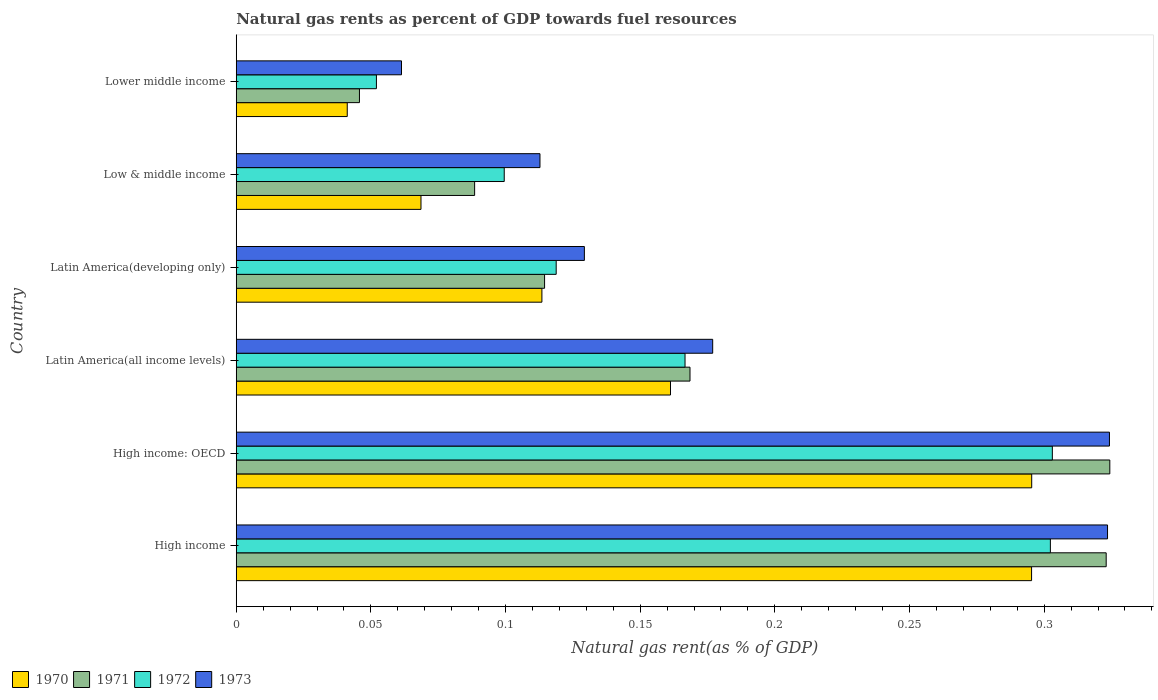How many groups of bars are there?
Offer a very short reply. 6. Are the number of bars on each tick of the Y-axis equal?
Offer a very short reply. Yes. How many bars are there on the 1st tick from the bottom?
Your answer should be very brief. 4. What is the label of the 3rd group of bars from the top?
Provide a short and direct response. Latin America(developing only). What is the natural gas rent in 1973 in Low & middle income?
Keep it short and to the point. 0.11. Across all countries, what is the maximum natural gas rent in 1970?
Provide a short and direct response. 0.3. Across all countries, what is the minimum natural gas rent in 1970?
Provide a short and direct response. 0.04. In which country was the natural gas rent in 1970 maximum?
Your answer should be compact. High income: OECD. In which country was the natural gas rent in 1973 minimum?
Your response must be concise. Lower middle income. What is the total natural gas rent in 1971 in the graph?
Your response must be concise. 1.06. What is the difference between the natural gas rent in 1973 in High income: OECD and that in Latin America(developing only)?
Offer a very short reply. 0.19. What is the difference between the natural gas rent in 1973 in High income and the natural gas rent in 1972 in High income: OECD?
Offer a very short reply. 0.02. What is the average natural gas rent in 1972 per country?
Ensure brevity in your answer.  0.17. What is the difference between the natural gas rent in 1972 and natural gas rent in 1973 in High income: OECD?
Offer a very short reply. -0.02. What is the ratio of the natural gas rent in 1971 in High income to that in Latin America(all income levels)?
Provide a succinct answer. 1.92. Is the difference between the natural gas rent in 1972 in High income and Latin America(all income levels) greater than the difference between the natural gas rent in 1973 in High income and Latin America(all income levels)?
Provide a succinct answer. No. What is the difference between the highest and the second highest natural gas rent in 1970?
Offer a terse response. 4.502023738700567e-5. What is the difference between the highest and the lowest natural gas rent in 1972?
Your answer should be compact. 0.25. In how many countries, is the natural gas rent in 1970 greater than the average natural gas rent in 1970 taken over all countries?
Give a very brief answer. 2. Is it the case that in every country, the sum of the natural gas rent in 1972 and natural gas rent in 1970 is greater than the sum of natural gas rent in 1973 and natural gas rent in 1971?
Your response must be concise. No. What does the 1st bar from the top in Latin America(all income levels) represents?
Your answer should be very brief. 1973. What does the 1st bar from the bottom in Latin America(all income levels) represents?
Your answer should be compact. 1970. How many bars are there?
Offer a very short reply. 24. Are all the bars in the graph horizontal?
Make the answer very short. Yes. What is the difference between two consecutive major ticks on the X-axis?
Provide a succinct answer. 0.05. How many legend labels are there?
Make the answer very short. 4. How are the legend labels stacked?
Provide a succinct answer. Horizontal. What is the title of the graph?
Offer a terse response. Natural gas rents as percent of GDP towards fuel resources. What is the label or title of the X-axis?
Keep it short and to the point. Natural gas rent(as % of GDP). What is the label or title of the Y-axis?
Provide a succinct answer. Country. What is the Natural gas rent(as % of GDP) in 1970 in High income?
Provide a succinct answer. 0.3. What is the Natural gas rent(as % of GDP) in 1971 in High income?
Keep it short and to the point. 0.32. What is the Natural gas rent(as % of GDP) of 1972 in High income?
Give a very brief answer. 0.3. What is the Natural gas rent(as % of GDP) in 1973 in High income?
Provide a short and direct response. 0.32. What is the Natural gas rent(as % of GDP) in 1970 in High income: OECD?
Provide a succinct answer. 0.3. What is the Natural gas rent(as % of GDP) in 1971 in High income: OECD?
Ensure brevity in your answer.  0.32. What is the Natural gas rent(as % of GDP) in 1972 in High income: OECD?
Offer a very short reply. 0.3. What is the Natural gas rent(as % of GDP) in 1973 in High income: OECD?
Offer a very short reply. 0.32. What is the Natural gas rent(as % of GDP) in 1970 in Latin America(all income levels)?
Give a very brief answer. 0.16. What is the Natural gas rent(as % of GDP) in 1971 in Latin America(all income levels)?
Keep it short and to the point. 0.17. What is the Natural gas rent(as % of GDP) of 1972 in Latin America(all income levels)?
Offer a very short reply. 0.17. What is the Natural gas rent(as % of GDP) in 1973 in Latin America(all income levels)?
Your answer should be very brief. 0.18. What is the Natural gas rent(as % of GDP) of 1970 in Latin America(developing only)?
Your answer should be very brief. 0.11. What is the Natural gas rent(as % of GDP) of 1971 in Latin America(developing only)?
Keep it short and to the point. 0.11. What is the Natural gas rent(as % of GDP) in 1972 in Latin America(developing only)?
Your answer should be very brief. 0.12. What is the Natural gas rent(as % of GDP) of 1973 in Latin America(developing only)?
Your response must be concise. 0.13. What is the Natural gas rent(as % of GDP) in 1970 in Low & middle income?
Make the answer very short. 0.07. What is the Natural gas rent(as % of GDP) of 1971 in Low & middle income?
Offer a terse response. 0.09. What is the Natural gas rent(as % of GDP) in 1972 in Low & middle income?
Provide a succinct answer. 0.1. What is the Natural gas rent(as % of GDP) in 1973 in Low & middle income?
Make the answer very short. 0.11. What is the Natural gas rent(as % of GDP) in 1970 in Lower middle income?
Offer a terse response. 0.04. What is the Natural gas rent(as % of GDP) of 1971 in Lower middle income?
Offer a terse response. 0.05. What is the Natural gas rent(as % of GDP) in 1972 in Lower middle income?
Ensure brevity in your answer.  0.05. What is the Natural gas rent(as % of GDP) in 1973 in Lower middle income?
Your response must be concise. 0.06. Across all countries, what is the maximum Natural gas rent(as % of GDP) of 1970?
Offer a terse response. 0.3. Across all countries, what is the maximum Natural gas rent(as % of GDP) of 1971?
Ensure brevity in your answer.  0.32. Across all countries, what is the maximum Natural gas rent(as % of GDP) in 1972?
Offer a very short reply. 0.3. Across all countries, what is the maximum Natural gas rent(as % of GDP) in 1973?
Make the answer very short. 0.32. Across all countries, what is the minimum Natural gas rent(as % of GDP) of 1970?
Your answer should be very brief. 0.04. Across all countries, what is the minimum Natural gas rent(as % of GDP) in 1971?
Provide a short and direct response. 0.05. Across all countries, what is the minimum Natural gas rent(as % of GDP) in 1972?
Your answer should be very brief. 0.05. Across all countries, what is the minimum Natural gas rent(as % of GDP) in 1973?
Give a very brief answer. 0.06. What is the total Natural gas rent(as % of GDP) in 1970 in the graph?
Ensure brevity in your answer.  0.98. What is the total Natural gas rent(as % of GDP) of 1971 in the graph?
Ensure brevity in your answer.  1.06. What is the total Natural gas rent(as % of GDP) of 1972 in the graph?
Ensure brevity in your answer.  1.04. What is the total Natural gas rent(as % of GDP) of 1973 in the graph?
Make the answer very short. 1.13. What is the difference between the Natural gas rent(as % of GDP) in 1971 in High income and that in High income: OECD?
Your response must be concise. -0. What is the difference between the Natural gas rent(as % of GDP) of 1972 in High income and that in High income: OECD?
Ensure brevity in your answer.  -0. What is the difference between the Natural gas rent(as % of GDP) in 1973 in High income and that in High income: OECD?
Your response must be concise. -0. What is the difference between the Natural gas rent(as % of GDP) of 1970 in High income and that in Latin America(all income levels)?
Keep it short and to the point. 0.13. What is the difference between the Natural gas rent(as % of GDP) of 1971 in High income and that in Latin America(all income levels)?
Offer a terse response. 0.15. What is the difference between the Natural gas rent(as % of GDP) of 1972 in High income and that in Latin America(all income levels)?
Make the answer very short. 0.14. What is the difference between the Natural gas rent(as % of GDP) in 1973 in High income and that in Latin America(all income levels)?
Provide a short and direct response. 0.15. What is the difference between the Natural gas rent(as % of GDP) in 1970 in High income and that in Latin America(developing only)?
Provide a succinct answer. 0.18. What is the difference between the Natural gas rent(as % of GDP) in 1971 in High income and that in Latin America(developing only)?
Keep it short and to the point. 0.21. What is the difference between the Natural gas rent(as % of GDP) in 1972 in High income and that in Latin America(developing only)?
Offer a very short reply. 0.18. What is the difference between the Natural gas rent(as % of GDP) in 1973 in High income and that in Latin America(developing only)?
Make the answer very short. 0.19. What is the difference between the Natural gas rent(as % of GDP) of 1970 in High income and that in Low & middle income?
Offer a very short reply. 0.23. What is the difference between the Natural gas rent(as % of GDP) of 1971 in High income and that in Low & middle income?
Keep it short and to the point. 0.23. What is the difference between the Natural gas rent(as % of GDP) in 1972 in High income and that in Low & middle income?
Provide a short and direct response. 0.2. What is the difference between the Natural gas rent(as % of GDP) of 1973 in High income and that in Low & middle income?
Ensure brevity in your answer.  0.21. What is the difference between the Natural gas rent(as % of GDP) of 1970 in High income and that in Lower middle income?
Provide a succinct answer. 0.25. What is the difference between the Natural gas rent(as % of GDP) of 1971 in High income and that in Lower middle income?
Your answer should be compact. 0.28. What is the difference between the Natural gas rent(as % of GDP) in 1972 in High income and that in Lower middle income?
Your response must be concise. 0.25. What is the difference between the Natural gas rent(as % of GDP) in 1973 in High income and that in Lower middle income?
Make the answer very short. 0.26. What is the difference between the Natural gas rent(as % of GDP) of 1970 in High income: OECD and that in Latin America(all income levels)?
Offer a terse response. 0.13. What is the difference between the Natural gas rent(as % of GDP) of 1971 in High income: OECD and that in Latin America(all income levels)?
Provide a succinct answer. 0.16. What is the difference between the Natural gas rent(as % of GDP) of 1972 in High income: OECD and that in Latin America(all income levels)?
Make the answer very short. 0.14. What is the difference between the Natural gas rent(as % of GDP) of 1973 in High income: OECD and that in Latin America(all income levels)?
Give a very brief answer. 0.15. What is the difference between the Natural gas rent(as % of GDP) in 1970 in High income: OECD and that in Latin America(developing only)?
Your answer should be very brief. 0.18. What is the difference between the Natural gas rent(as % of GDP) in 1971 in High income: OECD and that in Latin America(developing only)?
Your answer should be compact. 0.21. What is the difference between the Natural gas rent(as % of GDP) in 1972 in High income: OECD and that in Latin America(developing only)?
Offer a terse response. 0.18. What is the difference between the Natural gas rent(as % of GDP) of 1973 in High income: OECD and that in Latin America(developing only)?
Offer a terse response. 0.2. What is the difference between the Natural gas rent(as % of GDP) of 1970 in High income: OECD and that in Low & middle income?
Make the answer very short. 0.23. What is the difference between the Natural gas rent(as % of GDP) in 1971 in High income: OECD and that in Low & middle income?
Your answer should be compact. 0.24. What is the difference between the Natural gas rent(as % of GDP) of 1972 in High income: OECD and that in Low & middle income?
Keep it short and to the point. 0.2. What is the difference between the Natural gas rent(as % of GDP) in 1973 in High income: OECD and that in Low & middle income?
Your answer should be very brief. 0.21. What is the difference between the Natural gas rent(as % of GDP) of 1970 in High income: OECD and that in Lower middle income?
Offer a very short reply. 0.25. What is the difference between the Natural gas rent(as % of GDP) in 1971 in High income: OECD and that in Lower middle income?
Ensure brevity in your answer.  0.28. What is the difference between the Natural gas rent(as % of GDP) in 1972 in High income: OECD and that in Lower middle income?
Offer a terse response. 0.25. What is the difference between the Natural gas rent(as % of GDP) of 1973 in High income: OECD and that in Lower middle income?
Provide a succinct answer. 0.26. What is the difference between the Natural gas rent(as % of GDP) in 1970 in Latin America(all income levels) and that in Latin America(developing only)?
Your response must be concise. 0.05. What is the difference between the Natural gas rent(as % of GDP) in 1971 in Latin America(all income levels) and that in Latin America(developing only)?
Your answer should be very brief. 0.05. What is the difference between the Natural gas rent(as % of GDP) of 1972 in Latin America(all income levels) and that in Latin America(developing only)?
Offer a terse response. 0.05. What is the difference between the Natural gas rent(as % of GDP) in 1973 in Latin America(all income levels) and that in Latin America(developing only)?
Provide a succinct answer. 0.05. What is the difference between the Natural gas rent(as % of GDP) of 1970 in Latin America(all income levels) and that in Low & middle income?
Your answer should be compact. 0.09. What is the difference between the Natural gas rent(as % of GDP) of 1972 in Latin America(all income levels) and that in Low & middle income?
Provide a succinct answer. 0.07. What is the difference between the Natural gas rent(as % of GDP) of 1973 in Latin America(all income levels) and that in Low & middle income?
Your answer should be very brief. 0.06. What is the difference between the Natural gas rent(as % of GDP) of 1970 in Latin America(all income levels) and that in Lower middle income?
Offer a very short reply. 0.12. What is the difference between the Natural gas rent(as % of GDP) of 1971 in Latin America(all income levels) and that in Lower middle income?
Keep it short and to the point. 0.12. What is the difference between the Natural gas rent(as % of GDP) in 1972 in Latin America(all income levels) and that in Lower middle income?
Provide a short and direct response. 0.11. What is the difference between the Natural gas rent(as % of GDP) of 1973 in Latin America(all income levels) and that in Lower middle income?
Give a very brief answer. 0.12. What is the difference between the Natural gas rent(as % of GDP) of 1970 in Latin America(developing only) and that in Low & middle income?
Keep it short and to the point. 0.04. What is the difference between the Natural gas rent(as % of GDP) of 1971 in Latin America(developing only) and that in Low & middle income?
Keep it short and to the point. 0.03. What is the difference between the Natural gas rent(as % of GDP) in 1972 in Latin America(developing only) and that in Low & middle income?
Keep it short and to the point. 0.02. What is the difference between the Natural gas rent(as % of GDP) of 1973 in Latin America(developing only) and that in Low & middle income?
Offer a terse response. 0.02. What is the difference between the Natural gas rent(as % of GDP) of 1970 in Latin America(developing only) and that in Lower middle income?
Offer a very short reply. 0.07. What is the difference between the Natural gas rent(as % of GDP) in 1971 in Latin America(developing only) and that in Lower middle income?
Give a very brief answer. 0.07. What is the difference between the Natural gas rent(as % of GDP) of 1972 in Latin America(developing only) and that in Lower middle income?
Ensure brevity in your answer.  0.07. What is the difference between the Natural gas rent(as % of GDP) of 1973 in Latin America(developing only) and that in Lower middle income?
Your answer should be compact. 0.07. What is the difference between the Natural gas rent(as % of GDP) in 1970 in Low & middle income and that in Lower middle income?
Make the answer very short. 0.03. What is the difference between the Natural gas rent(as % of GDP) of 1971 in Low & middle income and that in Lower middle income?
Offer a terse response. 0.04. What is the difference between the Natural gas rent(as % of GDP) in 1972 in Low & middle income and that in Lower middle income?
Make the answer very short. 0.05. What is the difference between the Natural gas rent(as % of GDP) in 1973 in Low & middle income and that in Lower middle income?
Your response must be concise. 0.05. What is the difference between the Natural gas rent(as % of GDP) of 1970 in High income and the Natural gas rent(as % of GDP) of 1971 in High income: OECD?
Offer a very short reply. -0.03. What is the difference between the Natural gas rent(as % of GDP) in 1970 in High income and the Natural gas rent(as % of GDP) in 1972 in High income: OECD?
Your answer should be very brief. -0.01. What is the difference between the Natural gas rent(as % of GDP) of 1970 in High income and the Natural gas rent(as % of GDP) of 1973 in High income: OECD?
Your response must be concise. -0.03. What is the difference between the Natural gas rent(as % of GDP) in 1971 in High income and the Natural gas rent(as % of GDP) in 1973 in High income: OECD?
Provide a succinct answer. -0. What is the difference between the Natural gas rent(as % of GDP) in 1972 in High income and the Natural gas rent(as % of GDP) in 1973 in High income: OECD?
Provide a succinct answer. -0.02. What is the difference between the Natural gas rent(as % of GDP) of 1970 in High income and the Natural gas rent(as % of GDP) of 1971 in Latin America(all income levels)?
Ensure brevity in your answer.  0.13. What is the difference between the Natural gas rent(as % of GDP) in 1970 in High income and the Natural gas rent(as % of GDP) in 1972 in Latin America(all income levels)?
Offer a very short reply. 0.13. What is the difference between the Natural gas rent(as % of GDP) in 1970 in High income and the Natural gas rent(as % of GDP) in 1973 in Latin America(all income levels)?
Ensure brevity in your answer.  0.12. What is the difference between the Natural gas rent(as % of GDP) of 1971 in High income and the Natural gas rent(as % of GDP) of 1972 in Latin America(all income levels)?
Offer a very short reply. 0.16. What is the difference between the Natural gas rent(as % of GDP) of 1971 in High income and the Natural gas rent(as % of GDP) of 1973 in Latin America(all income levels)?
Your response must be concise. 0.15. What is the difference between the Natural gas rent(as % of GDP) in 1972 in High income and the Natural gas rent(as % of GDP) in 1973 in Latin America(all income levels)?
Your answer should be compact. 0.13. What is the difference between the Natural gas rent(as % of GDP) in 1970 in High income and the Natural gas rent(as % of GDP) in 1971 in Latin America(developing only)?
Keep it short and to the point. 0.18. What is the difference between the Natural gas rent(as % of GDP) of 1970 in High income and the Natural gas rent(as % of GDP) of 1972 in Latin America(developing only)?
Offer a terse response. 0.18. What is the difference between the Natural gas rent(as % of GDP) of 1970 in High income and the Natural gas rent(as % of GDP) of 1973 in Latin America(developing only)?
Your answer should be very brief. 0.17. What is the difference between the Natural gas rent(as % of GDP) of 1971 in High income and the Natural gas rent(as % of GDP) of 1972 in Latin America(developing only)?
Provide a succinct answer. 0.2. What is the difference between the Natural gas rent(as % of GDP) in 1971 in High income and the Natural gas rent(as % of GDP) in 1973 in Latin America(developing only)?
Make the answer very short. 0.19. What is the difference between the Natural gas rent(as % of GDP) of 1972 in High income and the Natural gas rent(as % of GDP) of 1973 in Latin America(developing only)?
Your answer should be compact. 0.17. What is the difference between the Natural gas rent(as % of GDP) in 1970 in High income and the Natural gas rent(as % of GDP) in 1971 in Low & middle income?
Keep it short and to the point. 0.21. What is the difference between the Natural gas rent(as % of GDP) in 1970 in High income and the Natural gas rent(as % of GDP) in 1972 in Low & middle income?
Make the answer very short. 0.2. What is the difference between the Natural gas rent(as % of GDP) in 1970 in High income and the Natural gas rent(as % of GDP) in 1973 in Low & middle income?
Provide a short and direct response. 0.18. What is the difference between the Natural gas rent(as % of GDP) in 1971 in High income and the Natural gas rent(as % of GDP) in 1972 in Low & middle income?
Your answer should be very brief. 0.22. What is the difference between the Natural gas rent(as % of GDP) in 1971 in High income and the Natural gas rent(as % of GDP) in 1973 in Low & middle income?
Ensure brevity in your answer.  0.21. What is the difference between the Natural gas rent(as % of GDP) in 1972 in High income and the Natural gas rent(as % of GDP) in 1973 in Low & middle income?
Your response must be concise. 0.19. What is the difference between the Natural gas rent(as % of GDP) in 1970 in High income and the Natural gas rent(as % of GDP) in 1971 in Lower middle income?
Provide a short and direct response. 0.25. What is the difference between the Natural gas rent(as % of GDP) of 1970 in High income and the Natural gas rent(as % of GDP) of 1972 in Lower middle income?
Your answer should be very brief. 0.24. What is the difference between the Natural gas rent(as % of GDP) in 1970 in High income and the Natural gas rent(as % of GDP) in 1973 in Lower middle income?
Your answer should be very brief. 0.23. What is the difference between the Natural gas rent(as % of GDP) of 1971 in High income and the Natural gas rent(as % of GDP) of 1972 in Lower middle income?
Offer a very short reply. 0.27. What is the difference between the Natural gas rent(as % of GDP) in 1971 in High income and the Natural gas rent(as % of GDP) in 1973 in Lower middle income?
Give a very brief answer. 0.26. What is the difference between the Natural gas rent(as % of GDP) of 1972 in High income and the Natural gas rent(as % of GDP) of 1973 in Lower middle income?
Offer a terse response. 0.24. What is the difference between the Natural gas rent(as % of GDP) of 1970 in High income: OECD and the Natural gas rent(as % of GDP) of 1971 in Latin America(all income levels)?
Keep it short and to the point. 0.13. What is the difference between the Natural gas rent(as % of GDP) in 1970 in High income: OECD and the Natural gas rent(as % of GDP) in 1972 in Latin America(all income levels)?
Your answer should be compact. 0.13. What is the difference between the Natural gas rent(as % of GDP) in 1970 in High income: OECD and the Natural gas rent(as % of GDP) in 1973 in Latin America(all income levels)?
Give a very brief answer. 0.12. What is the difference between the Natural gas rent(as % of GDP) in 1971 in High income: OECD and the Natural gas rent(as % of GDP) in 1972 in Latin America(all income levels)?
Your answer should be very brief. 0.16. What is the difference between the Natural gas rent(as % of GDP) in 1971 in High income: OECD and the Natural gas rent(as % of GDP) in 1973 in Latin America(all income levels)?
Your response must be concise. 0.15. What is the difference between the Natural gas rent(as % of GDP) in 1972 in High income: OECD and the Natural gas rent(as % of GDP) in 1973 in Latin America(all income levels)?
Give a very brief answer. 0.13. What is the difference between the Natural gas rent(as % of GDP) in 1970 in High income: OECD and the Natural gas rent(as % of GDP) in 1971 in Latin America(developing only)?
Your response must be concise. 0.18. What is the difference between the Natural gas rent(as % of GDP) of 1970 in High income: OECD and the Natural gas rent(as % of GDP) of 1972 in Latin America(developing only)?
Offer a very short reply. 0.18. What is the difference between the Natural gas rent(as % of GDP) of 1970 in High income: OECD and the Natural gas rent(as % of GDP) of 1973 in Latin America(developing only)?
Your answer should be compact. 0.17. What is the difference between the Natural gas rent(as % of GDP) of 1971 in High income: OECD and the Natural gas rent(as % of GDP) of 1972 in Latin America(developing only)?
Your response must be concise. 0.21. What is the difference between the Natural gas rent(as % of GDP) in 1971 in High income: OECD and the Natural gas rent(as % of GDP) in 1973 in Latin America(developing only)?
Offer a very short reply. 0.2. What is the difference between the Natural gas rent(as % of GDP) of 1972 in High income: OECD and the Natural gas rent(as % of GDP) of 1973 in Latin America(developing only)?
Give a very brief answer. 0.17. What is the difference between the Natural gas rent(as % of GDP) of 1970 in High income: OECD and the Natural gas rent(as % of GDP) of 1971 in Low & middle income?
Your answer should be very brief. 0.21. What is the difference between the Natural gas rent(as % of GDP) in 1970 in High income: OECD and the Natural gas rent(as % of GDP) in 1972 in Low & middle income?
Give a very brief answer. 0.2. What is the difference between the Natural gas rent(as % of GDP) of 1970 in High income: OECD and the Natural gas rent(as % of GDP) of 1973 in Low & middle income?
Offer a very short reply. 0.18. What is the difference between the Natural gas rent(as % of GDP) in 1971 in High income: OECD and the Natural gas rent(as % of GDP) in 1972 in Low & middle income?
Your answer should be compact. 0.22. What is the difference between the Natural gas rent(as % of GDP) in 1971 in High income: OECD and the Natural gas rent(as % of GDP) in 1973 in Low & middle income?
Make the answer very short. 0.21. What is the difference between the Natural gas rent(as % of GDP) of 1972 in High income: OECD and the Natural gas rent(as % of GDP) of 1973 in Low & middle income?
Your answer should be very brief. 0.19. What is the difference between the Natural gas rent(as % of GDP) of 1970 in High income: OECD and the Natural gas rent(as % of GDP) of 1971 in Lower middle income?
Offer a terse response. 0.25. What is the difference between the Natural gas rent(as % of GDP) of 1970 in High income: OECD and the Natural gas rent(as % of GDP) of 1972 in Lower middle income?
Provide a succinct answer. 0.24. What is the difference between the Natural gas rent(as % of GDP) of 1970 in High income: OECD and the Natural gas rent(as % of GDP) of 1973 in Lower middle income?
Provide a succinct answer. 0.23. What is the difference between the Natural gas rent(as % of GDP) of 1971 in High income: OECD and the Natural gas rent(as % of GDP) of 1972 in Lower middle income?
Your answer should be compact. 0.27. What is the difference between the Natural gas rent(as % of GDP) in 1971 in High income: OECD and the Natural gas rent(as % of GDP) in 1973 in Lower middle income?
Your answer should be compact. 0.26. What is the difference between the Natural gas rent(as % of GDP) of 1972 in High income: OECD and the Natural gas rent(as % of GDP) of 1973 in Lower middle income?
Provide a succinct answer. 0.24. What is the difference between the Natural gas rent(as % of GDP) of 1970 in Latin America(all income levels) and the Natural gas rent(as % of GDP) of 1971 in Latin America(developing only)?
Offer a very short reply. 0.05. What is the difference between the Natural gas rent(as % of GDP) of 1970 in Latin America(all income levels) and the Natural gas rent(as % of GDP) of 1972 in Latin America(developing only)?
Make the answer very short. 0.04. What is the difference between the Natural gas rent(as % of GDP) in 1970 in Latin America(all income levels) and the Natural gas rent(as % of GDP) in 1973 in Latin America(developing only)?
Make the answer very short. 0.03. What is the difference between the Natural gas rent(as % of GDP) in 1971 in Latin America(all income levels) and the Natural gas rent(as % of GDP) in 1972 in Latin America(developing only)?
Ensure brevity in your answer.  0.05. What is the difference between the Natural gas rent(as % of GDP) in 1971 in Latin America(all income levels) and the Natural gas rent(as % of GDP) in 1973 in Latin America(developing only)?
Your answer should be very brief. 0.04. What is the difference between the Natural gas rent(as % of GDP) of 1972 in Latin America(all income levels) and the Natural gas rent(as % of GDP) of 1973 in Latin America(developing only)?
Offer a very short reply. 0.04. What is the difference between the Natural gas rent(as % of GDP) in 1970 in Latin America(all income levels) and the Natural gas rent(as % of GDP) in 1971 in Low & middle income?
Provide a succinct answer. 0.07. What is the difference between the Natural gas rent(as % of GDP) of 1970 in Latin America(all income levels) and the Natural gas rent(as % of GDP) of 1972 in Low & middle income?
Ensure brevity in your answer.  0.06. What is the difference between the Natural gas rent(as % of GDP) in 1970 in Latin America(all income levels) and the Natural gas rent(as % of GDP) in 1973 in Low & middle income?
Provide a succinct answer. 0.05. What is the difference between the Natural gas rent(as % of GDP) of 1971 in Latin America(all income levels) and the Natural gas rent(as % of GDP) of 1972 in Low & middle income?
Your response must be concise. 0.07. What is the difference between the Natural gas rent(as % of GDP) in 1971 in Latin America(all income levels) and the Natural gas rent(as % of GDP) in 1973 in Low & middle income?
Keep it short and to the point. 0.06. What is the difference between the Natural gas rent(as % of GDP) of 1972 in Latin America(all income levels) and the Natural gas rent(as % of GDP) of 1973 in Low & middle income?
Provide a succinct answer. 0.05. What is the difference between the Natural gas rent(as % of GDP) of 1970 in Latin America(all income levels) and the Natural gas rent(as % of GDP) of 1971 in Lower middle income?
Ensure brevity in your answer.  0.12. What is the difference between the Natural gas rent(as % of GDP) in 1970 in Latin America(all income levels) and the Natural gas rent(as % of GDP) in 1972 in Lower middle income?
Provide a succinct answer. 0.11. What is the difference between the Natural gas rent(as % of GDP) in 1970 in Latin America(all income levels) and the Natural gas rent(as % of GDP) in 1973 in Lower middle income?
Provide a short and direct response. 0.1. What is the difference between the Natural gas rent(as % of GDP) in 1971 in Latin America(all income levels) and the Natural gas rent(as % of GDP) in 1972 in Lower middle income?
Your answer should be compact. 0.12. What is the difference between the Natural gas rent(as % of GDP) in 1971 in Latin America(all income levels) and the Natural gas rent(as % of GDP) in 1973 in Lower middle income?
Offer a very short reply. 0.11. What is the difference between the Natural gas rent(as % of GDP) of 1972 in Latin America(all income levels) and the Natural gas rent(as % of GDP) of 1973 in Lower middle income?
Provide a succinct answer. 0.11. What is the difference between the Natural gas rent(as % of GDP) of 1970 in Latin America(developing only) and the Natural gas rent(as % of GDP) of 1971 in Low & middle income?
Your answer should be very brief. 0.03. What is the difference between the Natural gas rent(as % of GDP) of 1970 in Latin America(developing only) and the Natural gas rent(as % of GDP) of 1972 in Low & middle income?
Your answer should be compact. 0.01. What is the difference between the Natural gas rent(as % of GDP) of 1970 in Latin America(developing only) and the Natural gas rent(as % of GDP) of 1973 in Low & middle income?
Your answer should be compact. 0. What is the difference between the Natural gas rent(as % of GDP) in 1971 in Latin America(developing only) and the Natural gas rent(as % of GDP) in 1972 in Low & middle income?
Provide a succinct answer. 0.01. What is the difference between the Natural gas rent(as % of GDP) of 1971 in Latin America(developing only) and the Natural gas rent(as % of GDP) of 1973 in Low & middle income?
Provide a succinct answer. 0. What is the difference between the Natural gas rent(as % of GDP) of 1972 in Latin America(developing only) and the Natural gas rent(as % of GDP) of 1973 in Low & middle income?
Keep it short and to the point. 0.01. What is the difference between the Natural gas rent(as % of GDP) in 1970 in Latin America(developing only) and the Natural gas rent(as % of GDP) in 1971 in Lower middle income?
Give a very brief answer. 0.07. What is the difference between the Natural gas rent(as % of GDP) in 1970 in Latin America(developing only) and the Natural gas rent(as % of GDP) in 1972 in Lower middle income?
Offer a terse response. 0.06. What is the difference between the Natural gas rent(as % of GDP) in 1970 in Latin America(developing only) and the Natural gas rent(as % of GDP) in 1973 in Lower middle income?
Provide a short and direct response. 0.05. What is the difference between the Natural gas rent(as % of GDP) of 1971 in Latin America(developing only) and the Natural gas rent(as % of GDP) of 1972 in Lower middle income?
Offer a terse response. 0.06. What is the difference between the Natural gas rent(as % of GDP) in 1971 in Latin America(developing only) and the Natural gas rent(as % of GDP) in 1973 in Lower middle income?
Ensure brevity in your answer.  0.05. What is the difference between the Natural gas rent(as % of GDP) in 1972 in Latin America(developing only) and the Natural gas rent(as % of GDP) in 1973 in Lower middle income?
Your answer should be very brief. 0.06. What is the difference between the Natural gas rent(as % of GDP) of 1970 in Low & middle income and the Natural gas rent(as % of GDP) of 1971 in Lower middle income?
Offer a very short reply. 0.02. What is the difference between the Natural gas rent(as % of GDP) of 1970 in Low & middle income and the Natural gas rent(as % of GDP) of 1972 in Lower middle income?
Offer a terse response. 0.02. What is the difference between the Natural gas rent(as % of GDP) in 1970 in Low & middle income and the Natural gas rent(as % of GDP) in 1973 in Lower middle income?
Ensure brevity in your answer.  0.01. What is the difference between the Natural gas rent(as % of GDP) of 1971 in Low & middle income and the Natural gas rent(as % of GDP) of 1972 in Lower middle income?
Offer a terse response. 0.04. What is the difference between the Natural gas rent(as % of GDP) in 1971 in Low & middle income and the Natural gas rent(as % of GDP) in 1973 in Lower middle income?
Make the answer very short. 0.03. What is the difference between the Natural gas rent(as % of GDP) of 1972 in Low & middle income and the Natural gas rent(as % of GDP) of 1973 in Lower middle income?
Your answer should be compact. 0.04. What is the average Natural gas rent(as % of GDP) of 1970 per country?
Give a very brief answer. 0.16. What is the average Natural gas rent(as % of GDP) of 1971 per country?
Make the answer very short. 0.18. What is the average Natural gas rent(as % of GDP) of 1972 per country?
Ensure brevity in your answer.  0.17. What is the average Natural gas rent(as % of GDP) in 1973 per country?
Keep it short and to the point. 0.19. What is the difference between the Natural gas rent(as % of GDP) of 1970 and Natural gas rent(as % of GDP) of 1971 in High income?
Ensure brevity in your answer.  -0.03. What is the difference between the Natural gas rent(as % of GDP) in 1970 and Natural gas rent(as % of GDP) in 1972 in High income?
Ensure brevity in your answer.  -0.01. What is the difference between the Natural gas rent(as % of GDP) in 1970 and Natural gas rent(as % of GDP) in 1973 in High income?
Ensure brevity in your answer.  -0.03. What is the difference between the Natural gas rent(as % of GDP) in 1971 and Natural gas rent(as % of GDP) in 1972 in High income?
Offer a terse response. 0.02. What is the difference between the Natural gas rent(as % of GDP) of 1971 and Natural gas rent(as % of GDP) of 1973 in High income?
Make the answer very short. -0. What is the difference between the Natural gas rent(as % of GDP) of 1972 and Natural gas rent(as % of GDP) of 1973 in High income?
Make the answer very short. -0.02. What is the difference between the Natural gas rent(as % of GDP) in 1970 and Natural gas rent(as % of GDP) in 1971 in High income: OECD?
Keep it short and to the point. -0.03. What is the difference between the Natural gas rent(as % of GDP) in 1970 and Natural gas rent(as % of GDP) in 1972 in High income: OECD?
Give a very brief answer. -0.01. What is the difference between the Natural gas rent(as % of GDP) of 1970 and Natural gas rent(as % of GDP) of 1973 in High income: OECD?
Offer a very short reply. -0.03. What is the difference between the Natural gas rent(as % of GDP) of 1971 and Natural gas rent(as % of GDP) of 1972 in High income: OECD?
Your answer should be very brief. 0.02. What is the difference between the Natural gas rent(as % of GDP) of 1971 and Natural gas rent(as % of GDP) of 1973 in High income: OECD?
Offer a terse response. 0. What is the difference between the Natural gas rent(as % of GDP) in 1972 and Natural gas rent(as % of GDP) in 1973 in High income: OECD?
Ensure brevity in your answer.  -0.02. What is the difference between the Natural gas rent(as % of GDP) of 1970 and Natural gas rent(as % of GDP) of 1971 in Latin America(all income levels)?
Your answer should be compact. -0.01. What is the difference between the Natural gas rent(as % of GDP) of 1970 and Natural gas rent(as % of GDP) of 1972 in Latin America(all income levels)?
Provide a succinct answer. -0.01. What is the difference between the Natural gas rent(as % of GDP) in 1970 and Natural gas rent(as % of GDP) in 1973 in Latin America(all income levels)?
Ensure brevity in your answer.  -0.02. What is the difference between the Natural gas rent(as % of GDP) of 1971 and Natural gas rent(as % of GDP) of 1972 in Latin America(all income levels)?
Ensure brevity in your answer.  0. What is the difference between the Natural gas rent(as % of GDP) of 1971 and Natural gas rent(as % of GDP) of 1973 in Latin America(all income levels)?
Ensure brevity in your answer.  -0.01. What is the difference between the Natural gas rent(as % of GDP) in 1972 and Natural gas rent(as % of GDP) in 1973 in Latin America(all income levels)?
Offer a very short reply. -0.01. What is the difference between the Natural gas rent(as % of GDP) of 1970 and Natural gas rent(as % of GDP) of 1971 in Latin America(developing only)?
Provide a short and direct response. -0. What is the difference between the Natural gas rent(as % of GDP) in 1970 and Natural gas rent(as % of GDP) in 1972 in Latin America(developing only)?
Ensure brevity in your answer.  -0.01. What is the difference between the Natural gas rent(as % of GDP) of 1970 and Natural gas rent(as % of GDP) of 1973 in Latin America(developing only)?
Give a very brief answer. -0.02. What is the difference between the Natural gas rent(as % of GDP) of 1971 and Natural gas rent(as % of GDP) of 1972 in Latin America(developing only)?
Provide a succinct answer. -0. What is the difference between the Natural gas rent(as % of GDP) in 1971 and Natural gas rent(as % of GDP) in 1973 in Latin America(developing only)?
Provide a succinct answer. -0.01. What is the difference between the Natural gas rent(as % of GDP) in 1972 and Natural gas rent(as % of GDP) in 1973 in Latin America(developing only)?
Offer a very short reply. -0.01. What is the difference between the Natural gas rent(as % of GDP) of 1970 and Natural gas rent(as % of GDP) of 1971 in Low & middle income?
Offer a very short reply. -0.02. What is the difference between the Natural gas rent(as % of GDP) of 1970 and Natural gas rent(as % of GDP) of 1972 in Low & middle income?
Ensure brevity in your answer.  -0.03. What is the difference between the Natural gas rent(as % of GDP) in 1970 and Natural gas rent(as % of GDP) in 1973 in Low & middle income?
Your answer should be compact. -0.04. What is the difference between the Natural gas rent(as % of GDP) of 1971 and Natural gas rent(as % of GDP) of 1972 in Low & middle income?
Your answer should be compact. -0.01. What is the difference between the Natural gas rent(as % of GDP) of 1971 and Natural gas rent(as % of GDP) of 1973 in Low & middle income?
Provide a short and direct response. -0.02. What is the difference between the Natural gas rent(as % of GDP) in 1972 and Natural gas rent(as % of GDP) in 1973 in Low & middle income?
Keep it short and to the point. -0.01. What is the difference between the Natural gas rent(as % of GDP) in 1970 and Natural gas rent(as % of GDP) in 1971 in Lower middle income?
Provide a short and direct response. -0. What is the difference between the Natural gas rent(as % of GDP) of 1970 and Natural gas rent(as % of GDP) of 1972 in Lower middle income?
Make the answer very short. -0.01. What is the difference between the Natural gas rent(as % of GDP) in 1970 and Natural gas rent(as % of GDP) in 1973 in Lower middle income?
Provide a succinct answer. -0.02. What is the difference between the Natural gas rent(as % of GDP) of 1971 and Natural gas rent(as % of GDP) of 1972 in Lower middle income?
Your answer should be compact. -0.01. What is the difference between the Natural gas rent(as % of GDP) in 1971 and Natural gas rent(as % of GDP) in 1973 in Lower middle income?
Offer a very short reply. -0.02. What is the difference between the Natural gas rent(as % of GDP) in 1972 and Natural gas rent(as % of GDP) in 1973 in Lower middle income?
Your answer should be compact. -0.01. What is the ratio of the Natural gas rent(as % of GDP) in 1971 in High income to that in High income: OECD?
Provide a succinct answer. 1. What is the ratio of the Natural gas rent(as % of GDP) in 1973 in High income to that in High income: OECD?
Give a very brief answer. 1. What is the ratio of the Natural gas rent(as % of GDP) in 1970 in High income to that in Latin America(all income levels)?
Provide a succinct answer. 1.83. What is the ratio of the Natural gas rent(as % of GDP) of 1971 in High income to that in Latin America(all income levels)?
Ensure brevity in your answer.  1.92. What is the ratio of the Natural gas rent(as % of GDP) in 1972 in High income to that in Latin America(all income levels)?
Keep it short and to the point. 1.81. What is the ratio of the Natural gas rent(as % of GDP) of 1973 in High income to that in Latin America(all income levels)?
Your answer should be compact. 1.83. What is the ratio of the Natural gas rent(as % of GDP) of 1970 in High income to that in Latin America(developing only)?
Give a very brief answer. 2.6. What is the ratio of the Natural gas rent(as % of GDP) of 1971 in High income to that in Latin America(developing only)?
Your response must be concise. 2.82. What is the ratio of the Natural gas rent(as % of GDP) of 1972 in High income to that in Latin America(developing only)?
Ensure brevity in your answer.  2.54. What is the ratio of the Natural gas rent(as % of GDP) of 1973 in High income to that in Latin America(developing only)?
Ensure brevity in your answer.  2.5. What is the ratio of the Natural gas rent(as % of GDP) of 1970 in High income to that in Low & middle income?
Give a very brief answer. 4.31. What is the ratio of the Natural gas rent(as % of GDP) of 1971 in High income to that in Low & middle income?
Keep it short and to the point. 3.65. What is the ratio of the Natural gas rent(as % of GDP) in 1972 in High income to that in Low & middle income?
Your answer should be very brief. 3.04. What is the ratio of the Natural gas rent(as % of GDP) in 1973 in High income to that in Low & middle income?
Your answer should be very brief. 2.87. What is the ratio of the Natural gas rent(as % of GDP) of 1970 in High income to that in Lower middle income?
Your answer should be very brief. 7.16. What is the ratio of the Natural gas rent(as % of GDP) in 1971 in High income to that in Lower middle income?
Ensure brevity in your answer.  7.06. What is the ratio of the Natural gas rent(as % of GDP) in 1972 in High income to that in Lower middle income?
Give a very brief answer. 5.81. What is the ratio of the Natural gas rent(as % of GDP) in 1973 in High income to that in Lower middle income?
Ensure brevity in your answer.  5.27. What is the ratio of the Natural gas rent(as % of GDP) of 1970 in High income: OECD to that in Latin America(all income levels)?
Offer a terse response. 1.83. What is the ratio of the Natural gas rent(as % of GDP) in 1971 in High income: OECD to that in Latin America(all income levels)?
Give a very brief answer. 1.93. What is the ratio of the Natural gas rent(as % of GDP) in 1972 in High income: OECD to that in Latin America(all income levels)?
Ensure brevity in your answer.  1.82. What is the ratio of the Natural gas rent(as % of GDP) of 1973 in High income: OECD to that in Latin America(all income levels)?
Offer a terse response. 1.83. What is the ratio of the Natural gas rent(as % of GDP) in 1970 in High income: OECD to that in Latin America(developing only)?
Provide a succinct answer. 2.6. What is the ratio of the Natural gas rent(as % of GDP) of 1971 in High income: OECD to that in Latin America(developing only)?
Offer a terse response. 2.83. What is the ratio of the Natural gas rent(as % of GDP) in 1972 in High income: OECD to that in Latin America(developing only)?
Your answer should be very brief. 2.55. What is the ratio of the Natural gas rent(as % of GDP) of 1973 in High income: OECD to that in Latin America(developing only)?
Ensure brevity in your answer.  2.51. What is the ratio of the Natural gas rent(as % of GDP) in 1970 in High income: OECD to that in Low & middle income?
Give a very brief answer. 4.31. What is the ratio of the Natural gas rent(as % of GDP) of 1971 in High income: OECD to that in Low & middle income?
Ensure brevity in your answer.  3.66. What is the ratio of the Natural gas rent(as % of GDP) in 1972 in High income: OECD to that in Low & middle income?
Provide a short and direct response. 3.05. What is the ratio of the Natural gas rent(as % of GDP) of 1973 in High income: OECD to that in Low & middle income?
Your answer should be compact. 2.88. What is the ratio of the Natural gas rent(as % of GDP) in 1970 in High income: OECD to that in Lower middle income?
Ensure brevity in your answer.  7.17. What is the ratio of the Natural gas rent(as % of GDP) of 1971 in High income: OECD to that in Lower middle income?
Give a very brief answer. 7.09. What is the ratio of the Natural gas rent(as % of GDP) in 1972 in High income: OECD to that in Lower middle income?
Provide a short and direct response. 5.82. What is the ratio of the Natural gas rent(as % of GDP) in 1973 in High income: OECD to that in Lower middle income?
Provide a succinct answer. 5.28. What is the ratio of the Natural gas rent(as % of GDP) in 1970 in Latin America(all income levels) to that in Latin America(developing only)?
Give a very brief answer. 1.42. What is the ratio of the Natural gas rent(as % of GDP) of 1971 in Latin America(all income levels) to that in Latin America(developing only)?
Offer a very short reply. 1.47. What is the ratio of the Natural gas rent(as % of GDP) in 1972 in Latin America(all income levels) to that in Latin America(developing only)?
Offer a very short reply. 1.4. What is the ratio of the Natural gas rent(as % of GDP) of 1973 in Latin America(all income levels) to that in Latin America(developing only)?
Your answer should be compact. 1.37. What is the ratio of the Natural gas rent(as % of GDP) in 1970 in Latin America(all income levels) to that in Low & middle income?
Keep it short and to the point. 2.35. What is the ratio of the Natural gas rent(as % of GDP) in 1971 in Latin America(all income levels) to that in Low & middle income?
Provide a short and direct response. 1.9. What is the ratio of the Natural gas rent(as % of GDP) of 1972 in Latin America(all income levels) to that in Low & middle income?
Your response must be concise. 1.67. What is the ratio of the Natural gas rent(as % of GDP) of 1973 in Latin America(all income levels) to that in Low & middle income?
Give a very brief answer. 1.57. What is the ratio of the Natural gas rent(as % of GDP) in 1970 in Latin America(all income levels) to that in Lower middle income?
Your answer should be very brief. 3.91. What is the ratio of the Natural gas rent(as % of GDP) of 1971 in Latin America(all income levels) to that in Lower middle income?
Your response must be concise. 3.68. What is the ratio of the Natural gas rent(as % of GDP) of 1972 in Latin America(all income levels) to that in Lower middle income?
Offer a very short reply. 3.2. What is the ratio of the Natural gas rent(as % of GDP) of 1973 in Latin America(all income levels) to that in Lower middle income?
Offer a very short reply. 2.88. What is the ratio of the Natural gas rent(as % of GDP) in 1970 in Latin America(developing only) to that in Low & middle income?
Keep it short and to the point. 1.65. What is the ratio of the Natural gas rent(as % of GDP) in 1971 in Latin America(developing only) to that in Low & middle income?
Offer a very short reply. 1.29. What is the ratio of the Natural gas rent(as % of GDP) of 1972 in Latin America(developing only) to that in Low & middle income?
Make the answer very short. 1.19. What is the ratio of the Natural gas rent(as % of GDP) in 1973 in Latin America(developing only) to that in Low & middle income?
Provide a succinct answer. 1.15. What is the ratio of the Natural gas rent(as % of GDP) in 1970 in Latin America(developing only) to that in Lower middle income?
Provide a short and direct response. 2.75. What is the ratio of the Natural gas rent(as % of GDP) in 1971 in Latin America(developing only) to that in Lower middle income?
Give a very brief answer. 2.5. What is the ratio of the Natural gas rent(as % of GDP) of 1972 in Latin America(developing only) to that in Lower middle income?
Ensure brevity in your answer.  2.28. What is the ratio of the Natural gas rent(as % of GDP) of 1973 in Latin America(developing only) to that in Lower middle income?
Provide a short and direct response. 2.11. What is the ratio of the Natural gas rent(as % of GDP) of 1970 in Low & middle income to that in Lower middle income?
Keep it short and to the point. 1.66. What is the ratio of the Natural gas rent(as % of GDP) of 1971 in Low & middle income to that in Lower middle income?
Give a very brief answer. 1.93. What is the ratio of the Natural gas rent(as % of GDP) in 1972 in Low & middle income to that in Lower middle income?
Ensure brevity in your answer.  1.91. What is the ratio of the Natural gas rent(as % of GDP) of 1973 in Low & middle income to that in Lower middle income?
Provide a short and direct response. 1.84. What is the difference between the highest and the second highest Natural gas rent(as % of GDP) of 1971?
Make the answer very short. 0. What is the difference between the highest and the second highest Natural gas rent(as % of GDP) of 1972?
Your response must be concise. 0. What is the difference between the highest and the second highest Natural gas rent(as % of GDP) of 1973?
Offer a very short reply. 0. What is the difference between the highest and the lowest Natural gas rent(as % of GDP) in 1970?
Your response must be concise. 0.25. What is the difference between the highest and the lowest Natural gas rent(as % of GDP) of 1971?
Offer a very short reply. 0.28. What is the difference between the highest and the lowest Natural gas rent(as % of GDP) of 1972?
Keep it short and to the point. 0.25. What is the difference between the highest and the lowest Natural gas rent(as % of GDP) in 1973?
Make the answer very short. 0.26. 